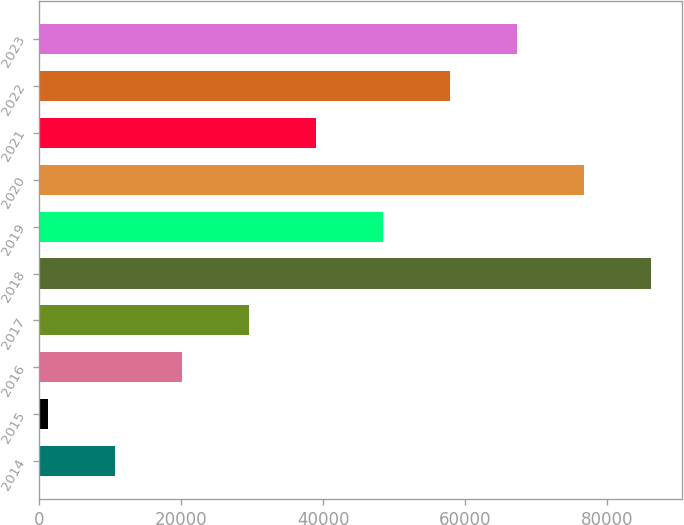Convert chart to OTSL. <chart><loc_0><loc_0><loc_500><loc_500><bar_chart><fcel>2014<fcel>2015<fcel>2016<fcel>2017<fcel>2018<fcel>2019<fcel>2020<fcel>2021<fcel>2022<fcel>2023<nl><fcel>10649.7<fcel>1196<fcel>20103.4<fcel>29557.1<fcel>86279.3<fcel>48464.5<fcel>76825.6<fcel>39010.8<fcel>57918.2<fcel>67371.9<nl></chart> 